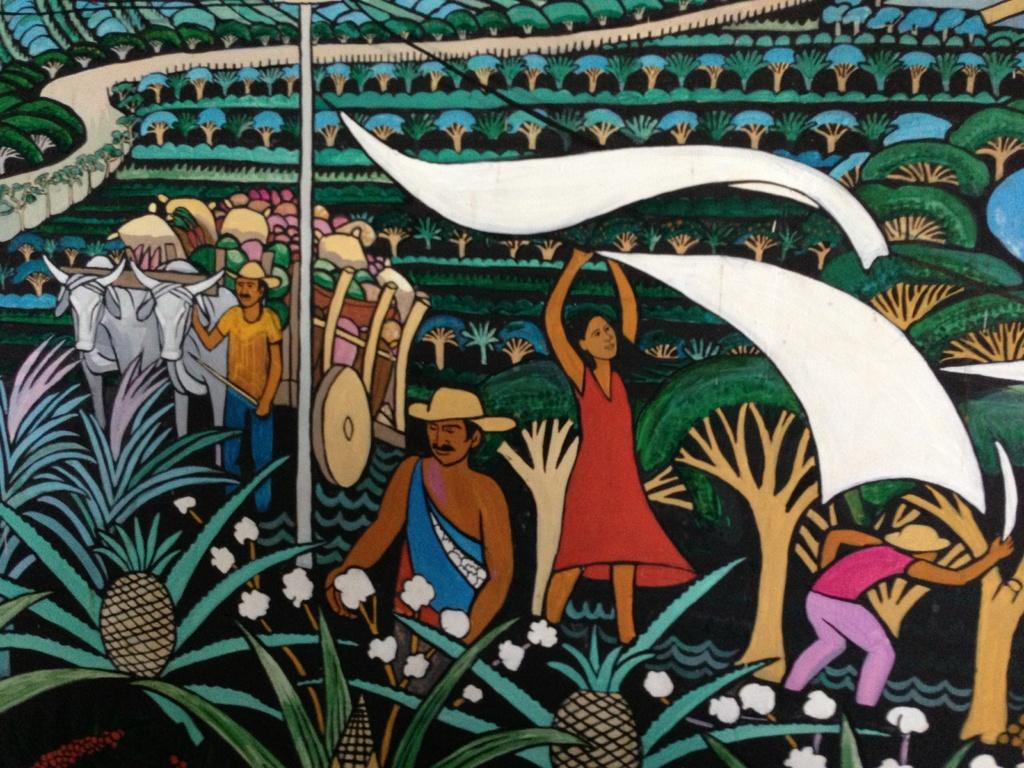What is depicted on the wall in the image? The wall has paintings of men, women, plants, trees, and a bullock cart. Can you describe the subjects of the paintings on the wall? The paintings on the wall include men, women, plants, trees, and a bullock cart. Are there any recurring themes or motifs in the paintings on the wall? The paintings on the wall depict various subjects, including people, plants, and animals. How many attempts does the train make to pass through the wall in the image? There is no train present in the image, so it is not possible to answer that question. 